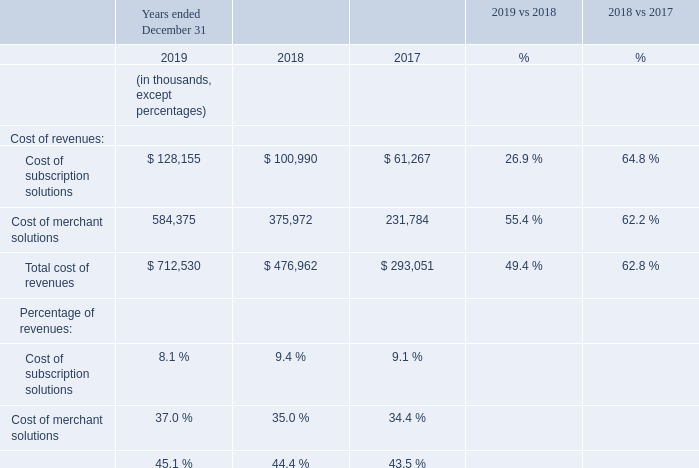Cost of Revenues
Cost of Subscription Solutions
Cost of subscription solutions increased $27.2 million, or 26.9%, for the year ended December 31, 2019 compared to the same period in 2018. The increase was primarily due to higher third-party infrastructure and hosting costs. The increase was also due to an increase in costs necessary to support a greater number of merchants using our platform, resulting in an increase in: credit card fees for processing merchant billings, employee-related costs, amortization of technology related to enhancing our platform, payments to third-party partners for the registration of domain names, and payments to third-party theme developers. As a percentage of revenues, costs of subscription solutions decreased from 9.4% in 2018 to 8.1% in 2019 due to a decrease in third-party infrastructure and hosting costs and employee-related costs as a percentage of revenue in 2019.
Cost of subscription solutions increased $39.7 million, or 64.8%, for the year ended December 31, 2018 compared to the same period in 2017. The increase was primarily due to higher third-party infrastructure and hosting costs as well as higher employee-related costs.
Cost of Merchant Solutions
Cost of merchant solutions increased $208.4 million, or 55.4%, for the year ended December 31, 2019 compared to the same period in 2018. The increase was primarily due to the increase in GMV facilitated through Shopify Payments, which resulted in higher payment processing and interchange fees. The increase was also due to higher amortization, largely related to the technology resulting from the 6RS acquisition, higher product costs associated with expanding our product offerings and higher credit card fees for processing merchant billings. Cost of merchant solutions as a percentage of revenues increased from 35.0% in 2018 to 37.0% in 2019, mainly as a result of Shopify Payments representing a larger percentage of total revenue.
Cost of merchant solutions increased $144.2 million, or 62.2%, for the year ended December 31, 2018 compared to the same period in 2017. The increase was primarily due to the increase in GMV facilitated through Shopify Payments, which resulted in payment processing fees, including interchange fees, increasing for the year ended December 31, 2018 as compared to the same period in 2017.
Which 2 financial items does cost of revenues consist of? Cost of subscription solutions, cost of merchant solutions. Which financial years' information does the table show (in chronological order)? 2017, 2018, 2019. What is the 2019 year ended cost of subscription solutions?
Answer scale should be: thousand. $ 128,155. Which year had the highest total cost of revenues? 712,530>476,962 , 712,530>293,051
Answer: 2019. Between year ended 2018 and 2019, which year had a higher cost of merchant solutions? 584,375>375,972
Answer: 2019. What's the total revenue in 2019?
Answer scale should be: thousand. 712,530/45.1 %
Answer: 1579889.14. 